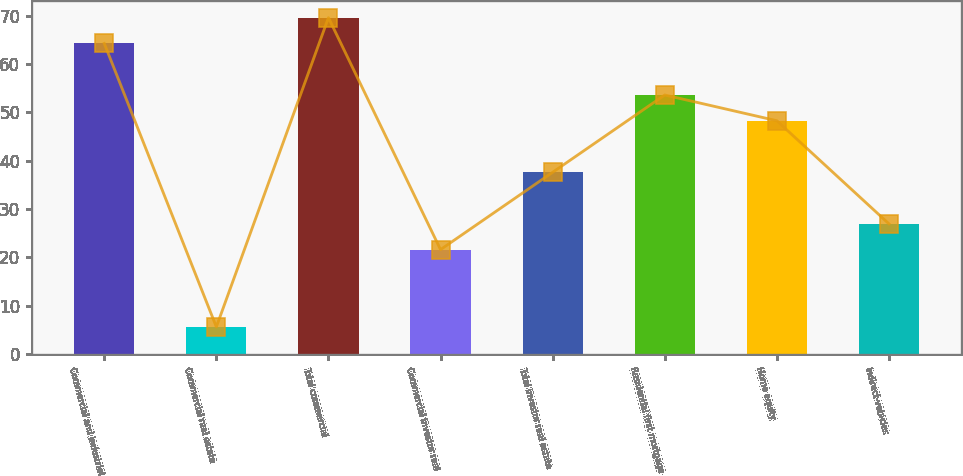Convert chart. <chart><loc_0><loc_0><loc_500><loc_500><bar_chart><fcel>Commercial and industrial<fcel>Commercial real estate<fcel>Total commercial<fcel>Commercial investor real<fcel>Total investor real estate<fcel>Residential first mortgage<fcel>Home equity<fcel>Indirect-vehicles<nl><fcel>64.26<fcel>5.63<fcel>69.59<fcel>21.62<fcel>37.61<fcel>53.6<fcel>48.27<fcel>26.95<nl></chart> 